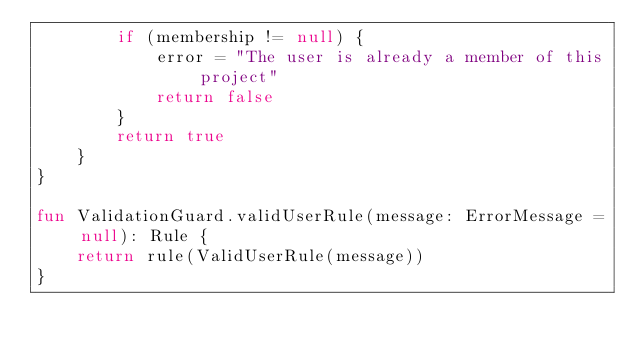<code> <loc_0><loc_0><loc_500><loc_500><_Kotlin_>        if (membership != null) {
            error = "The user is already a member of this project"
            return false
        }
        return true
    }
}

fun ValidationGuard.validUserRule(message: ErrorMessage = null): Rule {
    return rule(ValidUserRule(message))
}</code> 